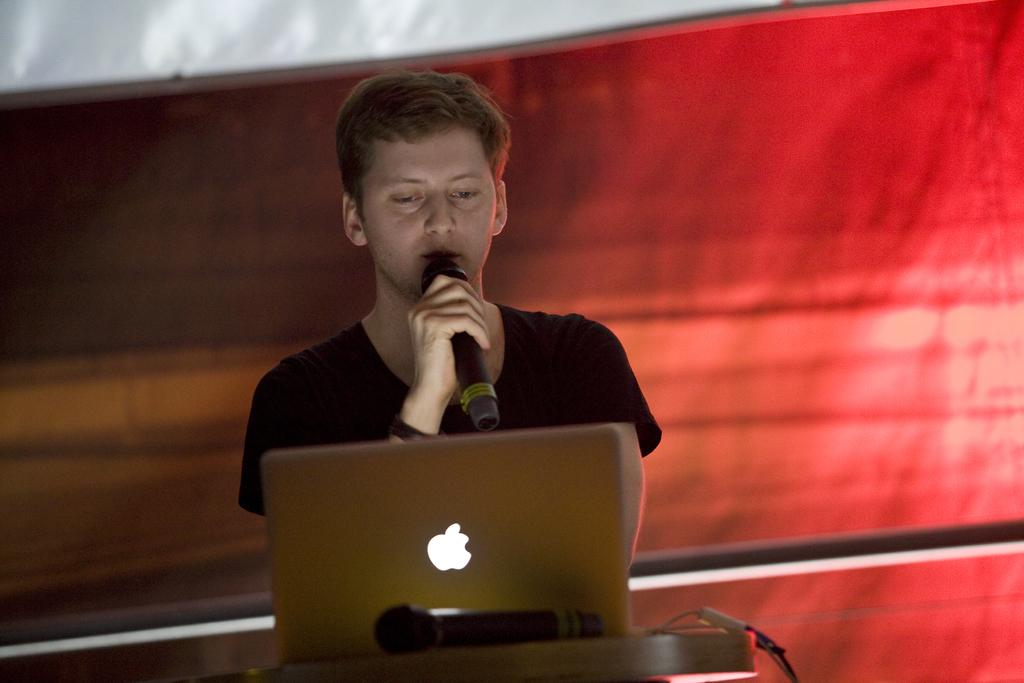Who or what is the main subject in the center of the image? There is a person in the center of the image. What is the person holding in their hand? The person is holding a microphone. What device is placed in front of the person? There is a laptop in front of the person. What color is the sheet behind the person? The sheet behind the person is red. Can you see a rabbit swimming in the image? No, there is no rabbit or swimming activity depicted in the image. 